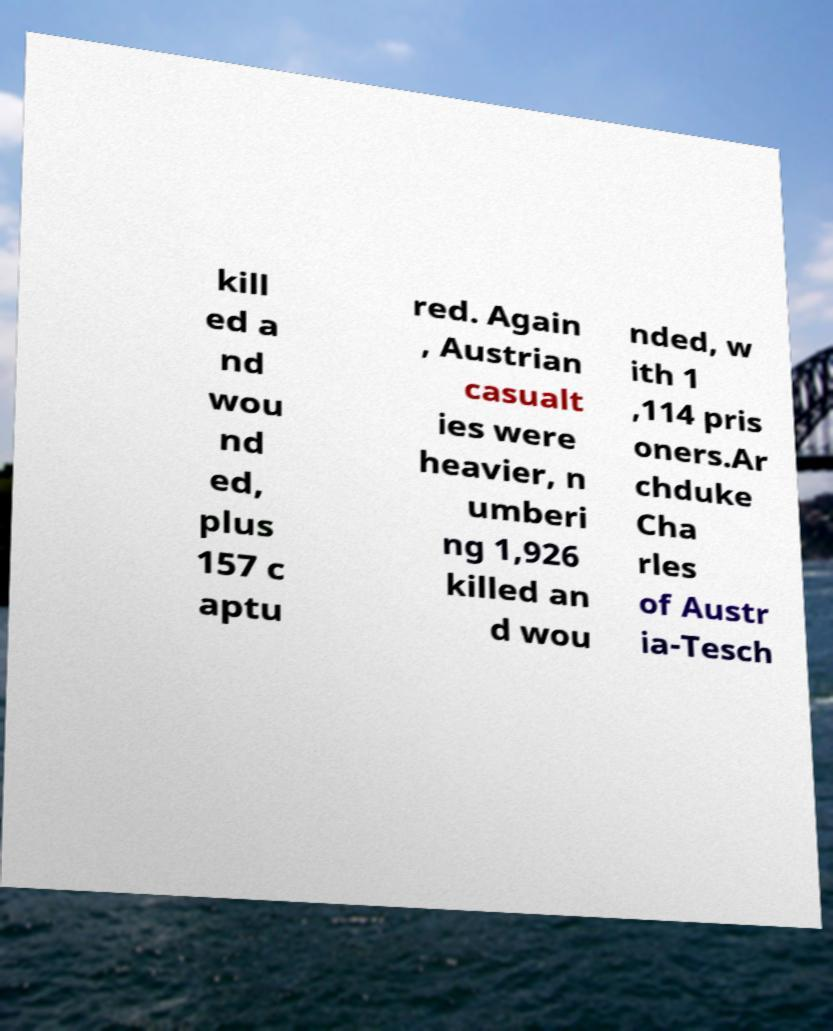Can you accurately transcribe the text from the provided image for me? kill ed a nd wou nd ed, plus 157 c aptu red. Again , Austrian casualt ies were heavier, n umberi ng 1,926 killed an d wou nded, w ith 1 ,114 pris oners.Ar chduke Cha rles of Austr ia-Tesch 